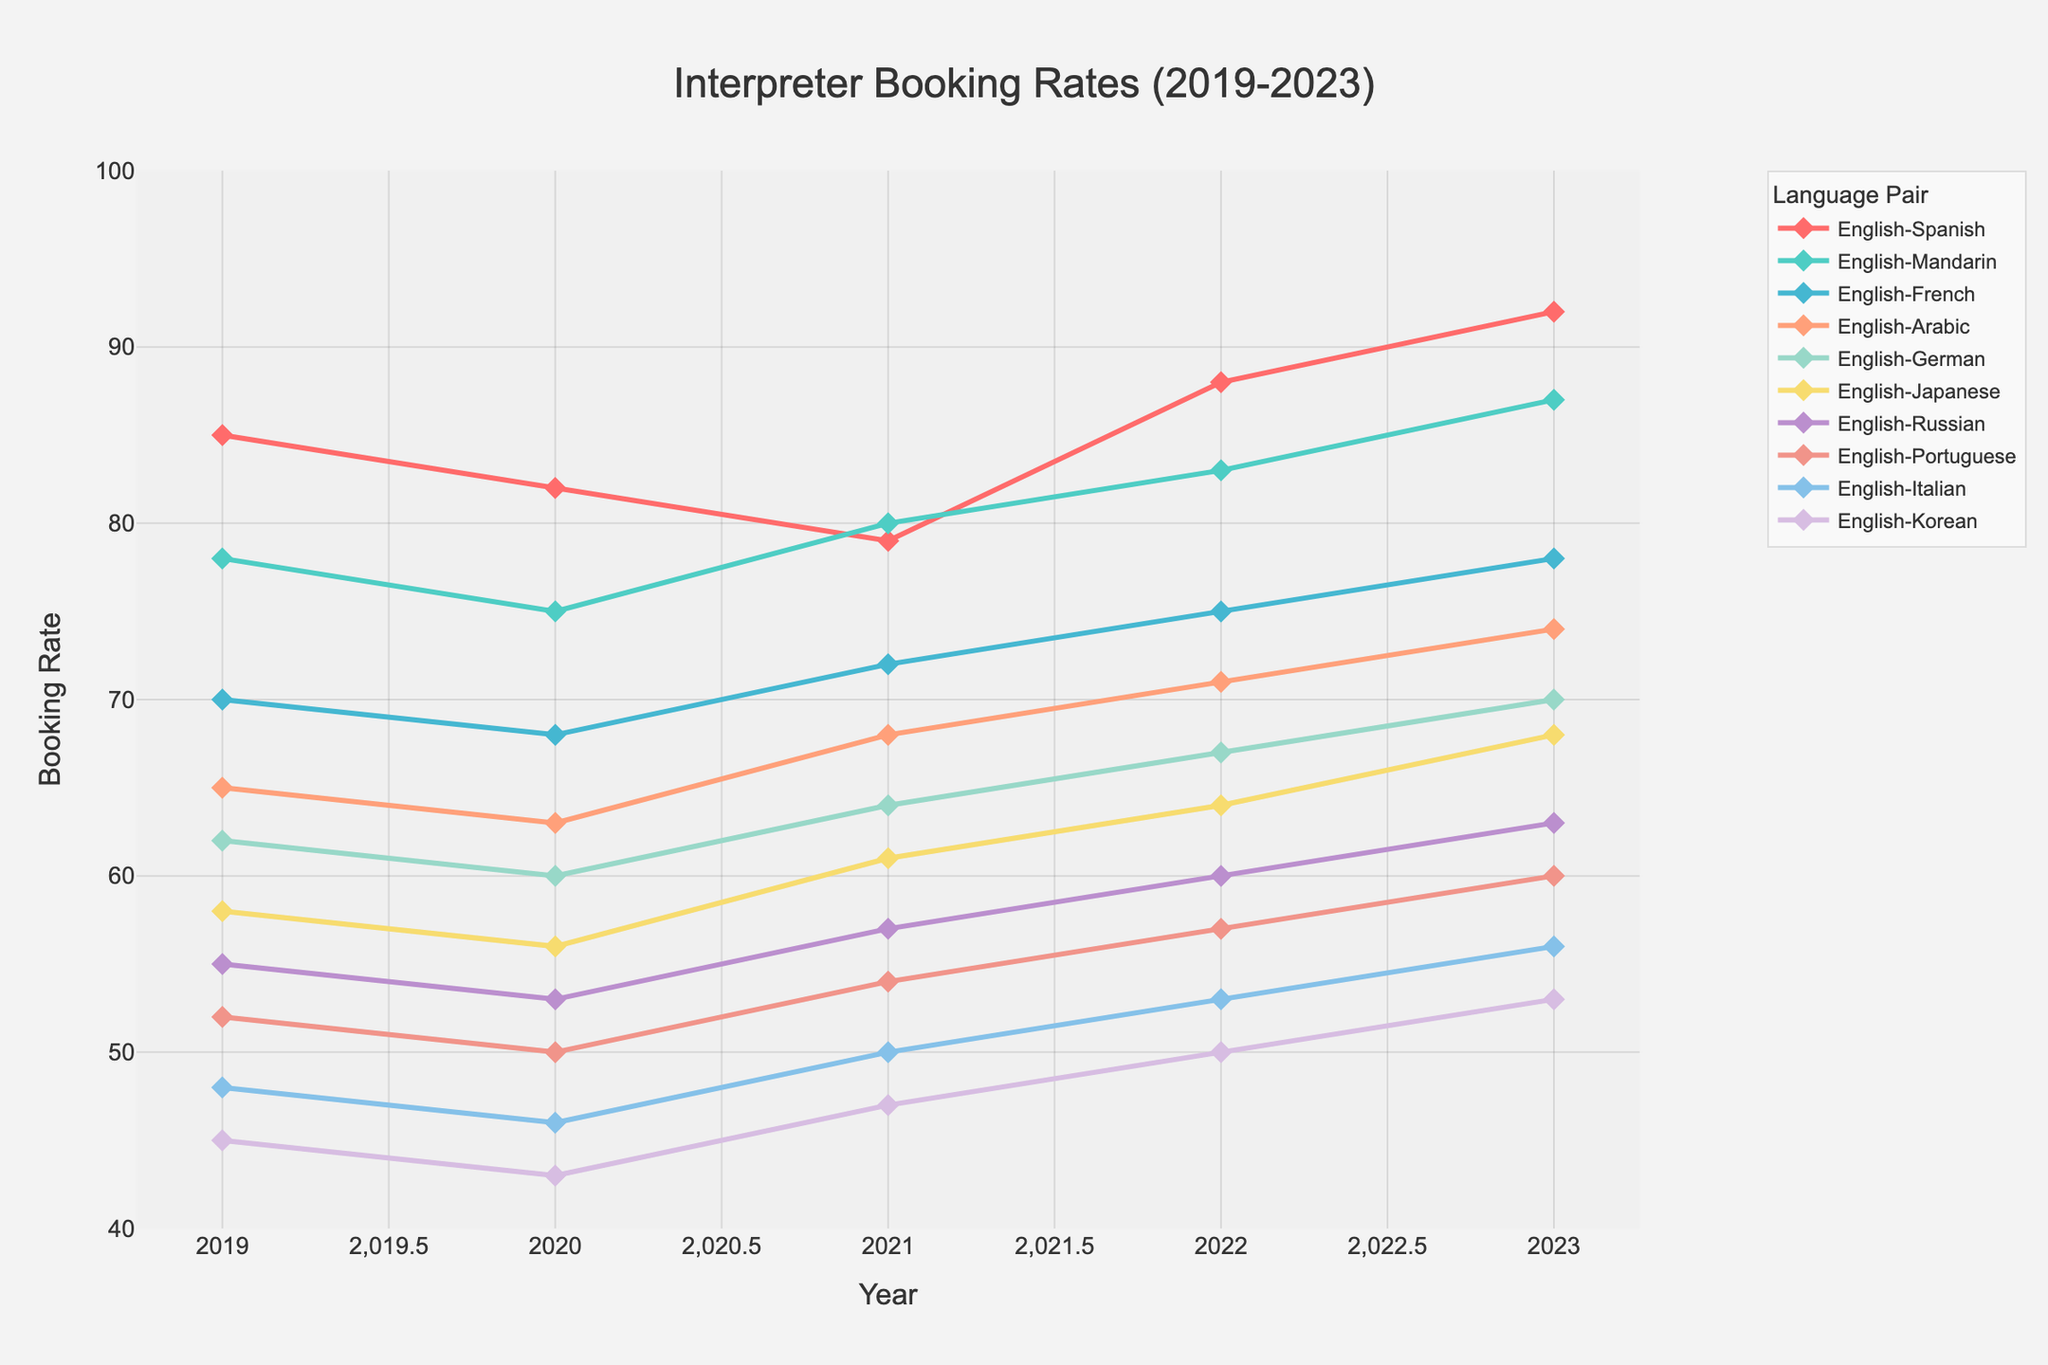What language pair had the highest booking rate in 2023? The highest booking rate in 2023 can be identified by looking at the points on the rightmost side of the plot and finding the maximum value. The highest value is 92, which corresponds to English-Spanish.
Answer: English-Spanish Which language pair had the largest increase in booking rate from 2020 to 2023? To find this, we calculate the difference in booking rates for each language pair between 2020 and 2023. English-Spanish: 92-82=10, English-Mandarin: 87-75=12, English-French: 78-68=10, English-Arabic: 74-63=11, English-German: 70-60=10, English-Japanese: 68-56=12, English-Russian: 63-53=10, English-Portuguese: 60-50=10, English-Italian: 56-46=10, English-Korean: 53-43=10. The largest increase is 12 for both English-Mandarin and English-Japanese.
Answer: English-Mandarin and English-Japanese What's the average booking rate for English-French over the 5 years? To get the average, sum the booking rates from 2019 to 2023 and divide by 5. (70 + 68 + 72 + 75 + 78) = 363 / 5 = 72.6
Answer: 72.6 Which language pair had the least variation in booking rates over the 5 years? Variation can be examined by calculating the range (highest value - lowest value) for each language pair. Compare the ranges to find the smallest. English-Spanish: 92-79=13, English-Mandarin: 87-75=12, English-French: 78-68=10, English-Arabic: 74-63=11, English-German: 70-60=10, English-Japanese: 68-56=12, English-Russian: 63-53=10, English-Portuguese: 60-50=10, English-Italian: 56-46=10, English-Korean: 53-43=10. Multiple pairs have a range of 10, the smallest variation.
Answer: English-French, English-German, English-Russian, English-Portuguese, English-Italian, English-Korean By how many booking points did English-Japanese increase from 2019 to 2023? Subtract the 2019 booking rate of English-Japanese from its 2023 rate. 68 - 58 = 10
Answer: 10 